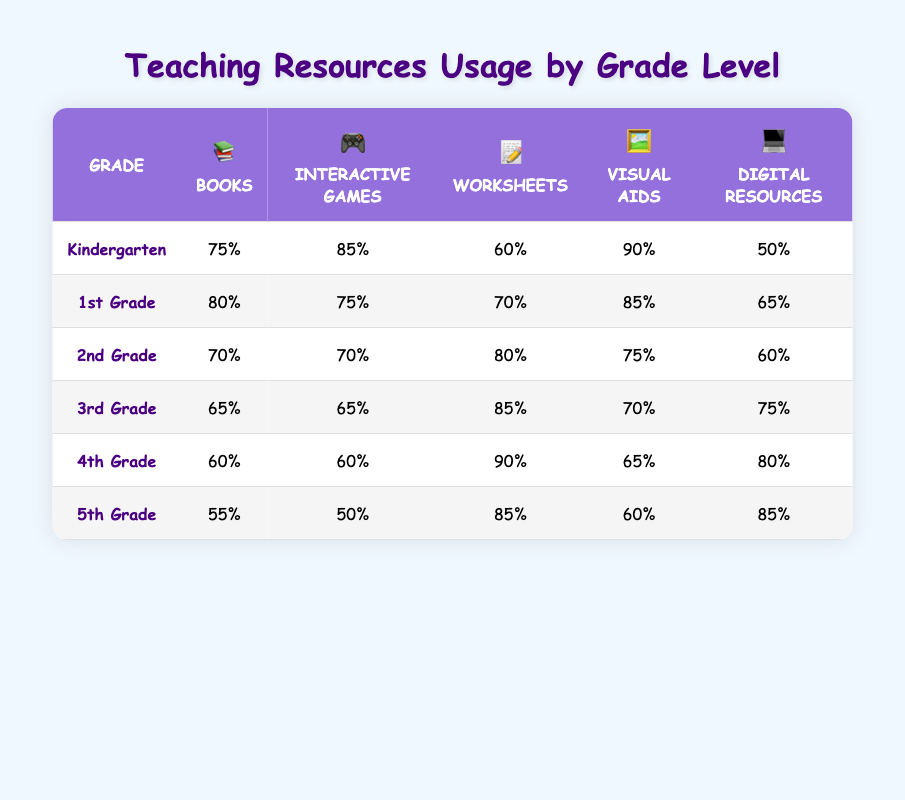What grade level uses the highest percentage of visual aids? From the table, Kindergarten has the highest percentage of visual aids usage at 90%. By checking the values in the visual aids column, we can see this is the maximum value compared to other grades.
Answer: Kindergarten How many resources does 5th grade use for interactive games? According to the table, 5th grade uses 50% of interactive games. This information can be directly found in the interactive games column of the 5th grade row.
Answer: 50% Which grade has the lowest percentage of books used? The table shows that 5th grade uses the lowest percentage of books at 55%. This can be determined by comparing the book usage percentages across all grades and observing that 55% is the smallest value.
Answer: 5th Grade What is the average percentage of worksheets used across all grades? The percentages of worksheets for each grade are: 60, 70, 80, 85, 90, and 85. First, we add these values: 60 + 70 + 80 + 85 + 90 + 85 = 460. Then we divide by the number of grades (6): 460 / 6 = approximately 76.67.
Answer: 76.67 Do 2nd graders use more digital resources than 1st graders? The table indicates 2nd grade has 60% of digital resources while 1st grade has 65%. By comparing these two values, we can conclude that 2nd graders use less digital resources.
Answer: No Which grade level has the same percentage of interactive games and books? By scanning the table, we can see that both 2nd grade and 1st grade have 70% usage of interactive games. Therefore, the only grade where these two percentages align is 2nd grade.
Answer: 2nd Grade What is the difference between the percentage of worksheets used in 4th and 1st grades? Looking at the table, 4th grade has 90% worksheets, while 1st grade has 70%. To find the difference, we subtract the values: 90 - 70 = 20.
Answer: 20% Do Kindergarten students use more digital resources than 3rd graders? From the row corresponding to Kindergarten, we see a usage of 50% digital resources. In contrast, 3rd graders use 75%. Thus, Kindergarten students use less digital resources.
Answer: No 